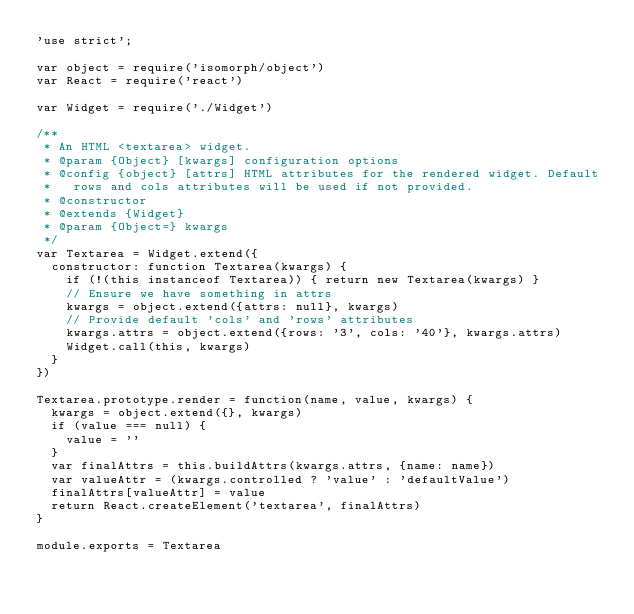Convert code to text. <code><loc_0><loc_0><loc_500><loc_500><_JavaScript_>'use strict';

var object = require('isomorph/object')
var React = require('react')

var Widget = require('./Widget')

/**
 * An HTML <textarea> widget.
 * @param {Object} [kwargs] configuration options
 * @config {object} [attrs] HTML attributes for the rendered widget. Default
 *   rows and cols attributes will be used if not provided.
 * @constructor
 * @extends {Widget}
 * @param {Object=} kwargs
 */
var Textarea = Widget.extend({
  constructor: function Textarea(kwargs) {
    if (!(this instanceof Textarea)) { return new Textarea(kwargs) }
    // Ensure we have something in attrs
    kwargs = object.extend({attrs: null}, kwargs)
    // Provide default 'cols' and 'rows' attributes
    kwargs.attrs = object.extend({rows: '3', cols: '40'}, kwargs.attrs)
    Widget.call(this, kwargs)
  }
})

Textarea.prototype.render = function(name, value, kwargs) {
  kwargs = object.extend({}, kwargs)
  if (value === null) {
    value = ''
  }
  var finalAttrs = this.buildAttrs(kwargs.attrs, {name: name})
  var valueAttr = (kwargs.controlled ? 'value' : 'defaultValue')
  finalAttrs[valueAttr] = value
  return React.createElement('textarea', finalAttrs)
}

module.exports = Textarea</code> 